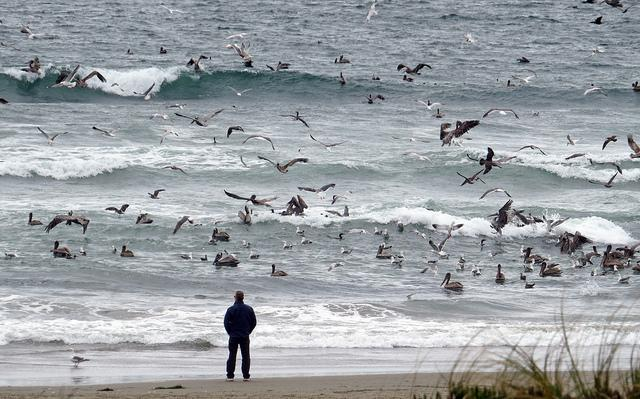What type of body of water are all of the birds gathering at? ocean 